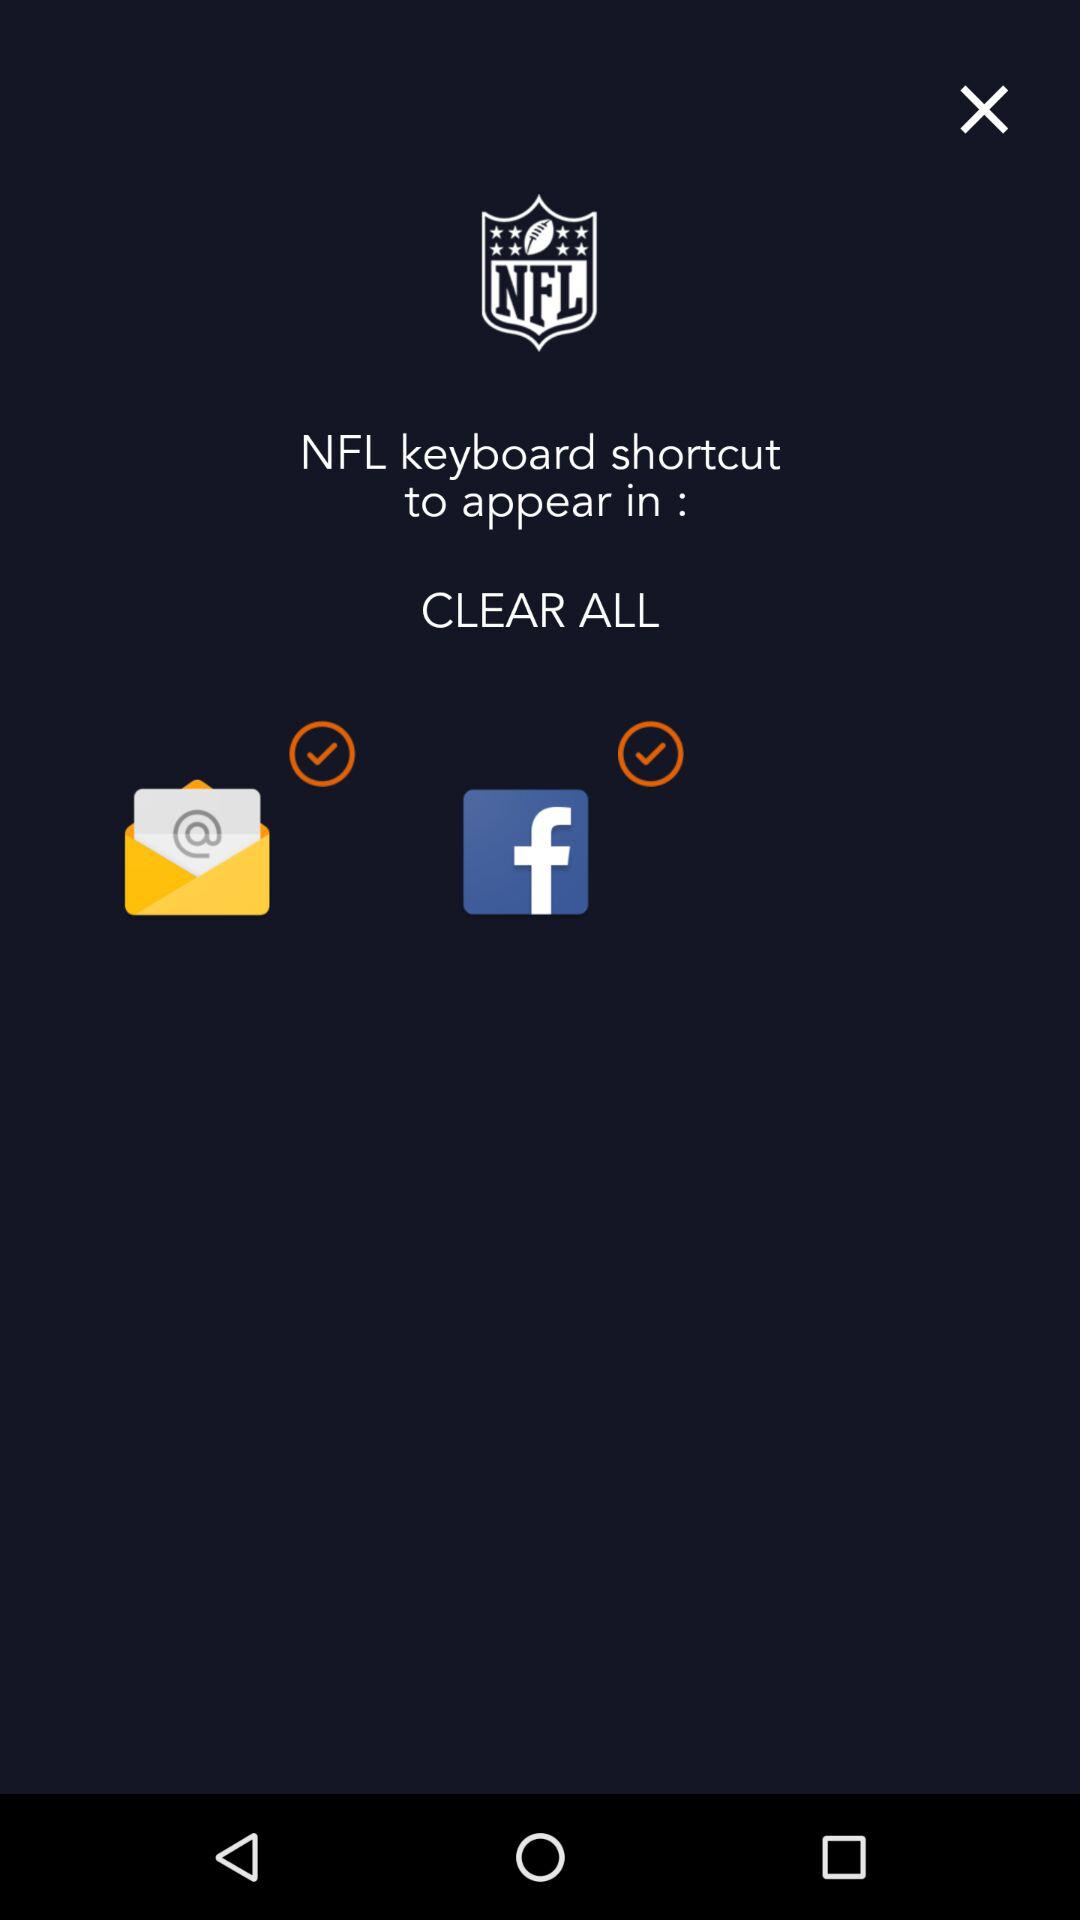What is the app name? The app name is "NFL". 